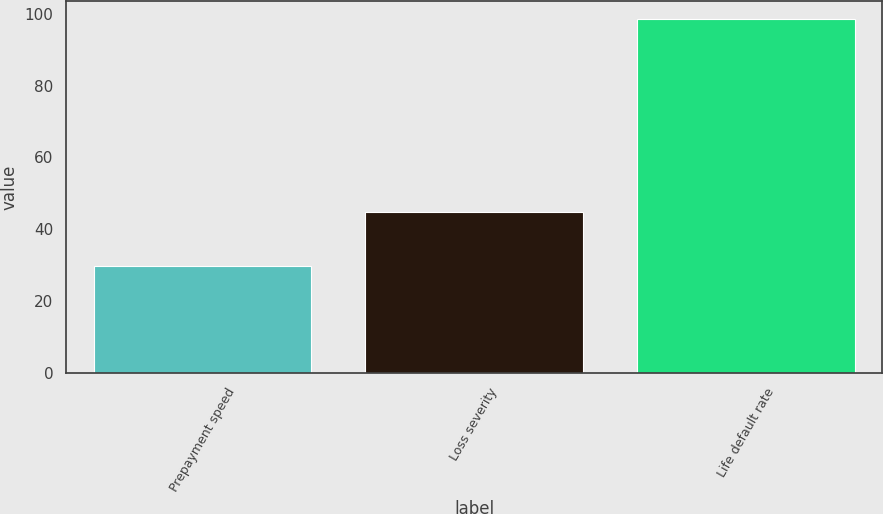Convert chart. <chart><loc_0><loc_0><loc_500><loc_500><bar_chart><fcel>Prepayment speed<fcel>Loss severity<fcel>Life default rate<nl><fcel>29.9<fcel>44.7<fcel>98.6<nl></chart> 